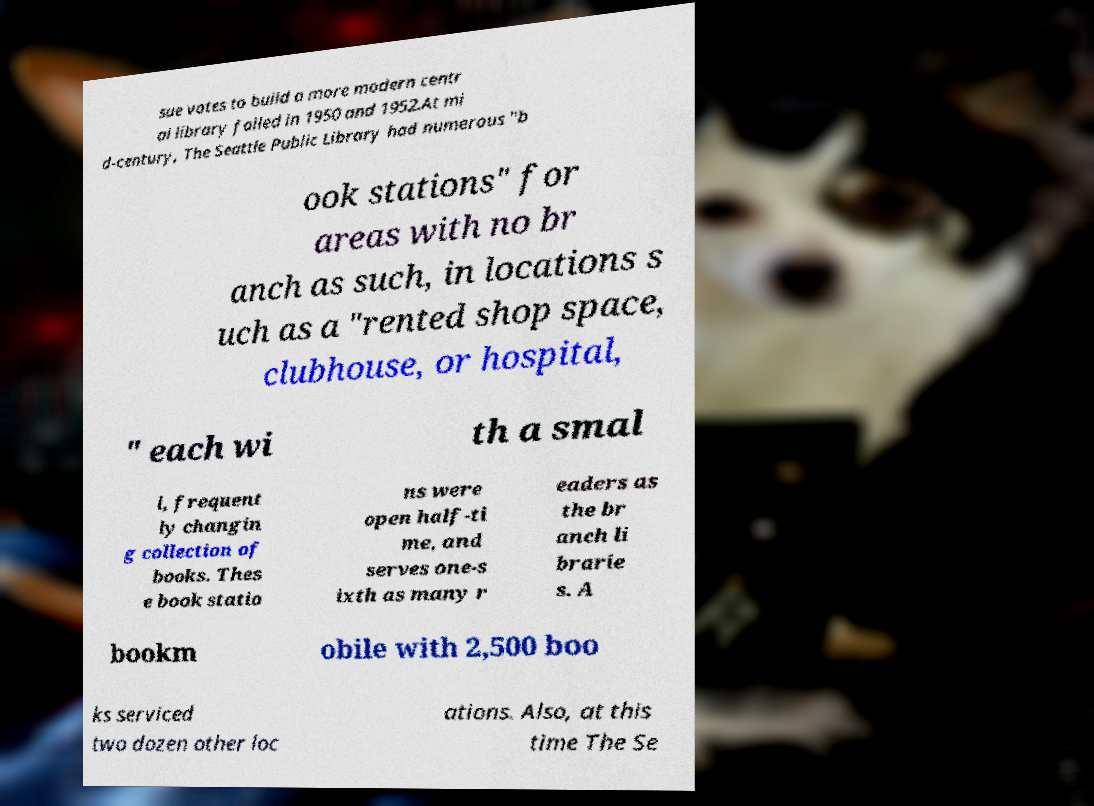Can you read and provide the text displayed in the image?This photo seems to have some interesting text. Can you extract and type it out for me? sue votes to build a more modern centr al library failed in 1950 and 1952.At mi d-century, The Seattle Public Library had numerous "b ook stations" for areas with no br anch as such, in locations s uch as a "rented shop space, clubhouse, or hospital, " each wi th a smal l, frequent ly changin g collection of books. Thes e book statio ns were open half-ti me, and serves one-s ixth as many r eaders as the br anch li brarie s. A bookm obile with 2,500 boo ks serviced two dozen other loc ations. Also, at this time The Se 